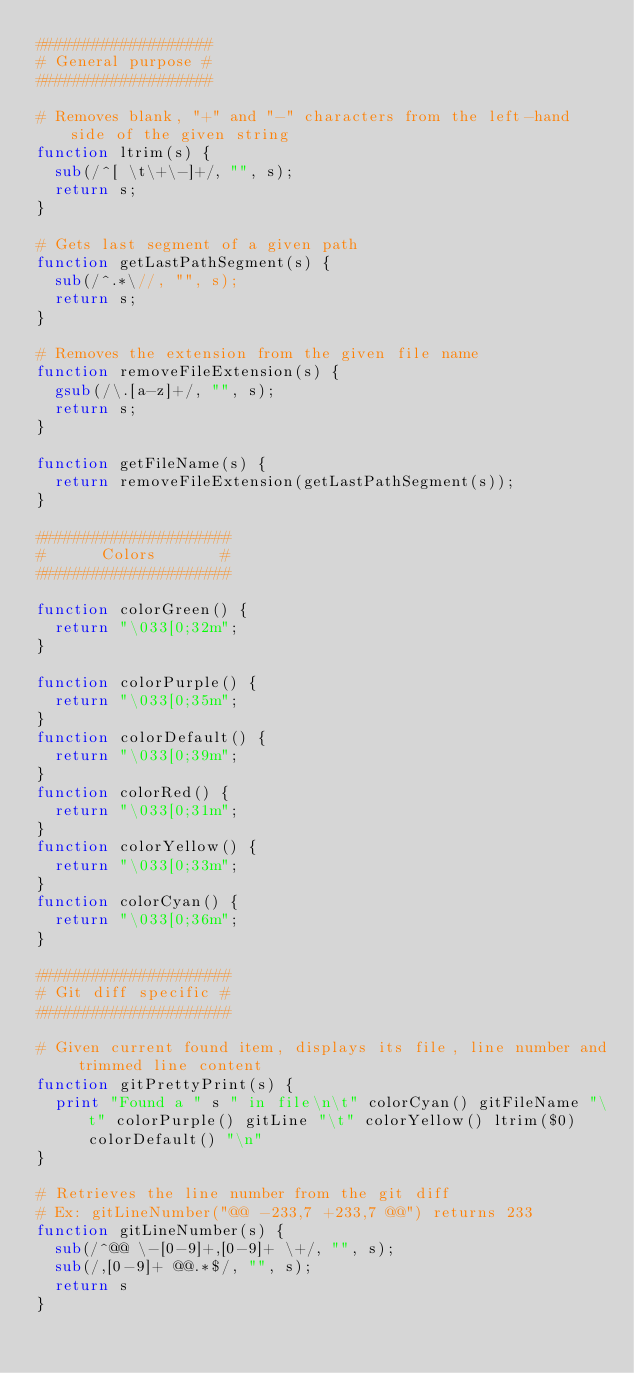<code> <loc_0><loc_0><loc_500><loc_500><_Awk_>###################
# General purpose #
###################

# Removes blank, "+" and "-" characters from the left-hand side of the given string
function ltrim(s) {
  sub(/^[ \t\+\-]+/, "", s);
  return s;
}

# Gets last segment of a given path
function getLastPathSegment(s) {
  sub(/^.*\//, "", s);
  return s;
}

# Removes the extension from the given file name
function removeFileExtension(s) {
  gsub(/\.[a-z]+/, "", s);
  return s;
}

function getFileName(s) {
  return removeFileExtension(getLastPathSegment(s));
}

#####################
#      Colors       #
#####################

function colorGreen() {
  return "\033[0;32m";
}

function colorPurple() {
  return "\033[0;35m";
}
function colorDefault() {
  return "\033[0;39m";
}
function colorRed() {
  return "\033[0;31m";
}
function colorYellow() {
  return "\033[0;33m";
}
function colorCyan() {
  return "\033[0;36m";
}

#####################
# Git diff specific #
#####################

# Given current found item, displays its file, line number and trimmed line content
function gitPrettyPrint(s) {
  print "Found a " s " in file\n\t" colorCyan() gitFileName "\t" colorPurple() gitLine "\t" colorYellow() ltrim($0) colorDefault() "\n"
}

# Retrieves the line number from the git diff
# Ex: gitLineNumber("@@ -233,7 +233,7 @@") returns 233
function gitLineNumber(s) {
  sub(/^@@ \-[0-9]+,[0-9]+ \+/, "", s);
  sub(/,[0-9]+ @@.*$/, "", s);
  return s
}
</code> 